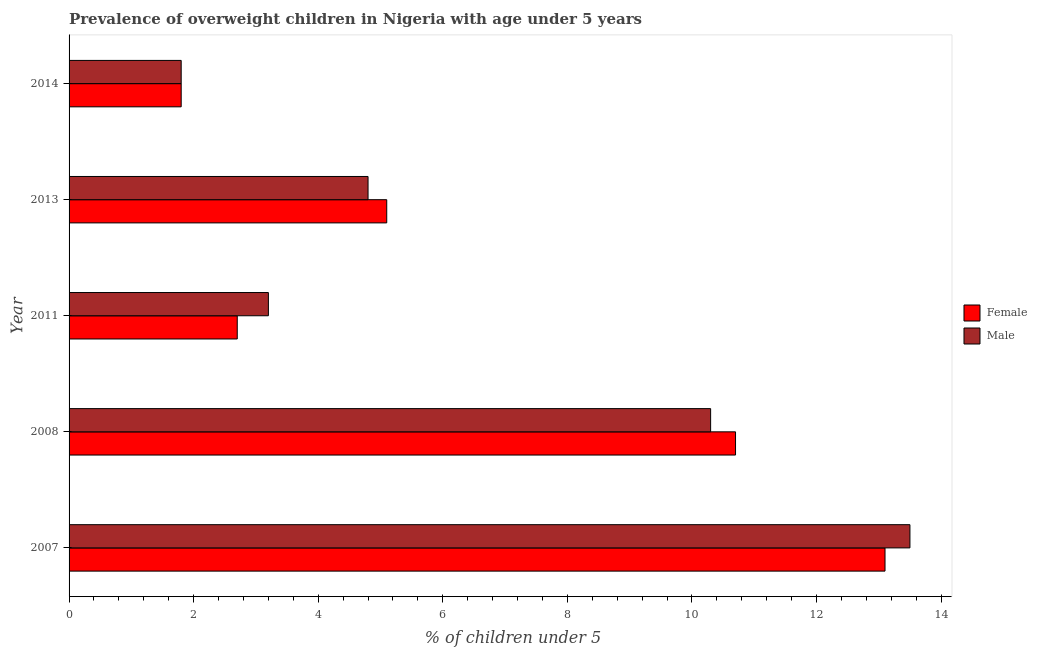Are the number of bars per tick equal to the number of legend labels?
Your answer should be very brief. Yes. Are the number of bars on each tick of the Y-axis equal?
Your response must be concise. Yes. How many bars are there on the 2nd tick from the top?
Give a very brief answer. 2. How many bars are there on the 1st tick from the bottom?
Make the answer very short. 2. What is the label of the 1st group of bars from the top?
Your answer should be compact. 2014. In how many cases, is the number of bars for a given year not equal to the number of legend labels?
Provide a succinct answer. 0. What is the percentage of obese female children in 2008?
Ensure brevity in your answer.  10.7. Across all years, what is the maximum percentage of obese male children?
Provide a succinct answer. 13.5. Across all years, what is the minimum percentage of obese female children?
Make the answer very short. 1.8. What is the total percentage of obese male children in the graph?
Your response must be concise. 33.6. What is the difference between the percentage of obese male children in 2007 and that in 2011?
Give a very brief answer. 10.3. What is the difference between the percentage of obese female children in 2008 and the percentage of obese male children in 2013?
Offer a very short reply. 5.9. What is the average percentage of obese male children per year?
Provide a succinct answer. 6.72. In the year 2014, what is the difference between the percentage of obese male children and percentage of obese female children?
Your answer should be very brief. 0. Is the percentage of obese male children in 2008 less than that in 2014?
Provide a short and direct response. No. What is the difference between the highest and the lowest percentage of obese male children?
Ensure brevity in your answer.  11.7. What does the 1st bar from the top in 2008 represents?
Offer a very short reply. Male. What is the difference between two consecutive major ticks on the X-axis?
Provide a succinct answer. 2. Where does the legend appear in the graph?
Your answer should be compact. Center right. How are the legend labels stacked?
Provide a short and direct response. Vertical. What is the title of the graph?
Ensure brevity in your answer.  Prevalence of overweight children in Nigeria with age under 5 years. Does "Commercial bank branches" appear as one of the legend labels in the graph?
Keep it short and to the point. No. What is the label or title of the X-axis?
Make the answer very short.  % of children under 5. What is the label or title of the Y-axis?
Make the answer very short. Year. What is the  % of children under 5 of Female in 2007?
Your response must be concise. 13.1. What is the  % of children under 5 in Male in 2007?
Your answer should be compact. 13.5. What is the  % of children under 5 in Female in 2008?
Keep it short and to the point. 10.7. What is the  % of children under 5 in Male in 2008?
Your response must be concise. 10.3. What is the  % of children under 5 of Female in 2011?
Provide a short and direct response. 2.7. What is the  % of children under 5 in Male in 2011?
Offer a very short reply. 3.2. What is the  % of children under 5 of Female in 2013?
Keep it short and to the point. 5.1. What is the  % of children under 5 of Male in 2013?
Provide a short and direct response. 4.8. What is the  % of children under 5 in Female in 2014?
Make the answer very short. 1.8. What is the  % of children under 5 in Male in 2014?
Your answer should be compact. 1.8. Across all years, what is the maximum  % of children under 5 of Female?
Provide a succinct answer. 13.1. Across all years, what is the minimum  % of children under 5 in Female?
Provide a short and direct response. 1.8. Across all years, what is the minimum  % of children under 5 of Male?
Give a very brief answer. 1.8. What is the total  % of children under 5 of Female in the graph?
Provide a short and direct response. 33.4. What is the total  % of children under 5 in Male in the graph?
Provide a succinct answer. 33.6. What is the difference between the  % of children under 5 of Female in 2007 and that in 2008?
Your answer should be compact. 2.4. What is the difference between the  % of children under 5 in Male in 2007 and that in 2008?
Make the answer very short. 3.2. What is the difference between the  % of children under 5 in Female in 2007 and that in 2011?
Your answer should be compact. 10.4. What is the difference between the  % of children under 5 of Male in 2007 and that in 2011?
Your answer should be compact. 10.3. What is the difference between the  % of children under 5 of Female in 2007 and that in 2013?
Provide a succinct answer. 8. What is the difference between the  % of children under 5 of Male in 2013 and that in 2014?
Offer a very short reply. 3. What is the difference between the  % of children under 5 in Female in 2007 and the  % of children under 5 in Male in 2008?
Your answer should be very brief. 2.8. What is the difference between the  % of children under 5 of Female in 2007 and the  % of children under 5 of Male in 2013?
Keep it short and to the point. 8.3. What is the difference between the  % of children under 5 of Female in 2008 and the  % of children under 5 of Male in 2011?
Provide a short and direct response. 7.5. What is the difference between the  % of children under 5 of Female in 2008 and the  % of children under 5 of Male in 2013?
Make the answer very short. 5.9. What is the difference between the  % of children under 5 in Female in 2008 and the  % of children under 5 in Male in 2014?
Give a very brief answer. 8.9. What is the difference between the  % of children under 5 in Female in 2011 and the  % of children under 5 in Male in 2013?
Offer a terse response. -2.1. What is the difference between the  % of children under 5 of Female in 2011 and the  % of children under 5 of Male in 2014?
Your response must be concise. 0.9. What is the average  % of children under 5 of Female per year?
Your answer should be compact. 6.68. What is the average  % of children under 5 in Male per year?
Make the answer very short. 6.72. In the year 2008, what is the difference between the  % of children under 5 of Female and  % of children under 5 of Male?
Provide a short and direct response. 0.4. In the year 2011, what is the difference between the  % of children under 5 of Female and  % of children under 5 of Male?
Provide a succinct answer. -0.5. In the year 2013, what is the difference between the  % of children under 5 in Female and  % of children under 5 in Male?
Ensure brevity in your answer.  0.3. What is the ratio of the  % of children under 5 in Female in 2007 to that in 2008?
Offer a very short reply. 1.22. What is the ratio of the  % of children under 5 in Male in 2007 to that in 2008?
Make the answer very short. 1.31. What is the ratio of the  % of children under 5 in Female in 2007 to that in 2011?
Provide a short and direct response. 4.85. What is the ratio of the  % of children under 5 of Male in 2007 to that in 2011?
Ensure brevity in your answer.  4.22. What is the ratio of the  % of children under 5 of Female in 2007 to that in 2013?
Keep it short and to the point. 2.57. What is the ratio of the  % of children under 5 of Male in 2007 to that in 2013?
Provide a short and direct response. 2.81. What is the ratio of the  % of children under 5 of Female in 2007 to that in 2014?
Give a very brief answer. 7.28. What is the ratio of the  % of children under 5 of Male in 2007 to that in 2014?
Make the answer very short. 7.5. What is the ratio of the  % of children under 5 in Female in 2008 to that in 2011?
Provide a succinct answer. 3.96. What is the ratio of the  % of children under 5 in Male in 2008 to that in 2011?
Keep it short and to the point. 3.22. What is the ratio of the  % of children under 5 in Female in 2008 to that in 2013?
Provide a succinct answer. 2.1. What is the ratio of the  % of children under 5 of Male in 2008 to that in 2013?
Give a very brief answer. 2.15. What is the ratio of the  % of children under 5 in Female in 2008 to that in 2014?
Provide a short and direct response. 5.94. What is the ratio of the  % of children under 5 in Male in 2008 to that in 2014?
Keep it short and to the point. 5.72. What is the ratio of the  % of children under 5 of Female in 2011 to that in 2013?
Provide a short and direct response. 0.53. What is the ratio of the  % of children under 5 of Female in 2011 to that in 2014?
Your response must be concise. 1.5. What is the ratio of the  % of children under 5 of Male in 2011 to that in 2014?
Offer a very short reply. 1.78. What is the ratio of the  % of children under 5 of Female in 2013 to that in 2014?
Make the answer very short. 2.83. What is the ratio of the  % of children under 5 in Male in 2013 to that in 2014?
Offer a very short reply. 2.67. What is the difference between the highest and the lowest  % of children under 5 of Female?
Your answer should be very brief. 11.3. What is the difference between the highest and the lowest  % of children under 5 in Male?
Ensure brevity in your answer.  11.7. 